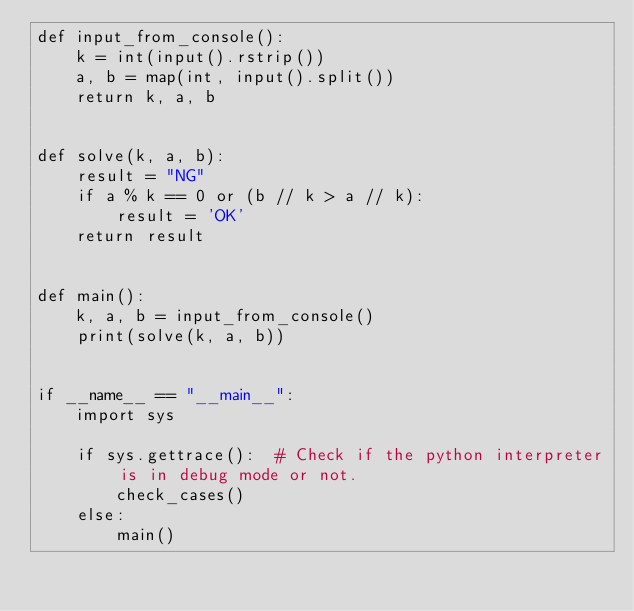<code> <loc_0><loc_0><loc_500><loc_500><_Python_>def input_from_console():
    k = int(input().rstrip())
    a, b = map(int, input().split())
    return k, a, b


def solve(k, a, b):
    result = "NG"
    if a % k == 0 or (b // k > a // k):
        result = 'OK'
    return result


def main():
    k, a, b = input_from_console()
    print(solve(k, a, b))


if __name__ == "__main__":
    import sys

    if sys.gettrace():  # Check if the python interpreter is in debug mode or not.
        check_cases()
    else:
        main()
</code> 